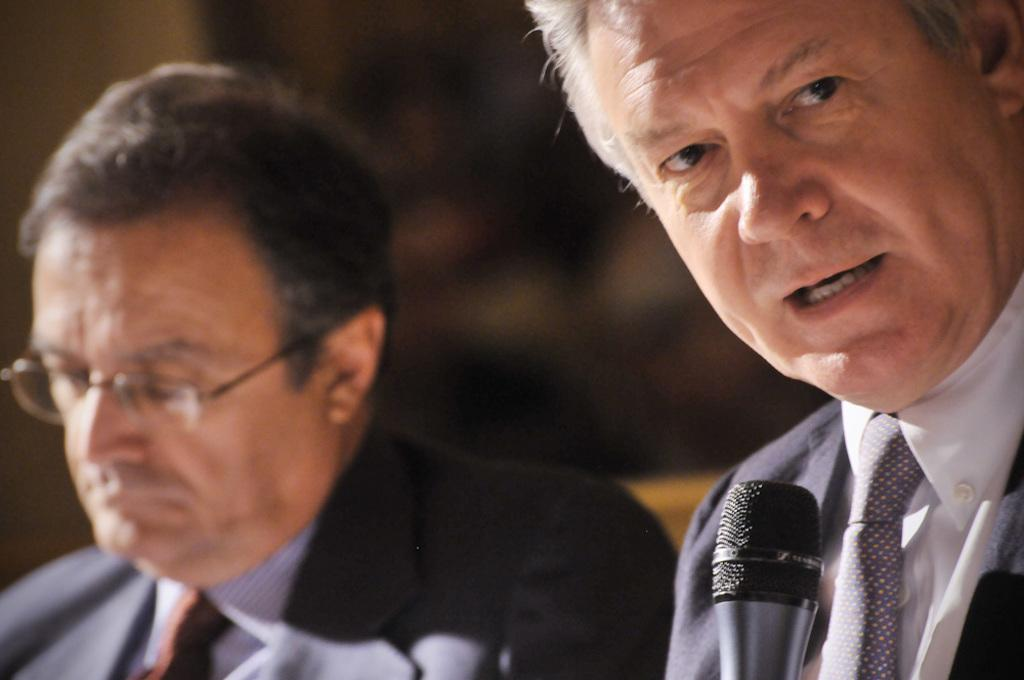How many people can be seen in the image? There are a few people in the image. What can be observed about the background of the image? The background of the image is blurred. What type of reaction can be seen from the fairies in the image? There are no fairies present in the image. How many cars are visible in the image? There are no cars visible in the image. 